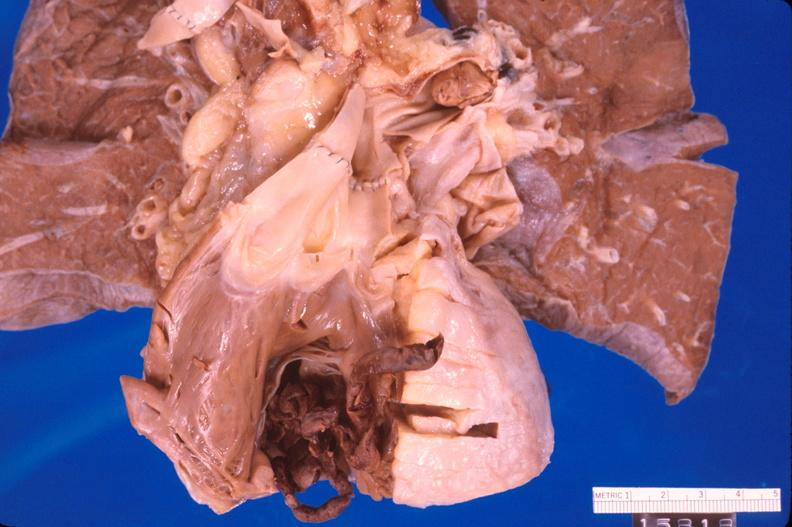s pus in test tube present?
Answer the question using a single word or phrase. No 